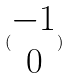<formula> <loc_0><loc_0><loc_500><loc_500>( \begin{matrix} - 1 \\ 0 \end{matrix} )</formula> 